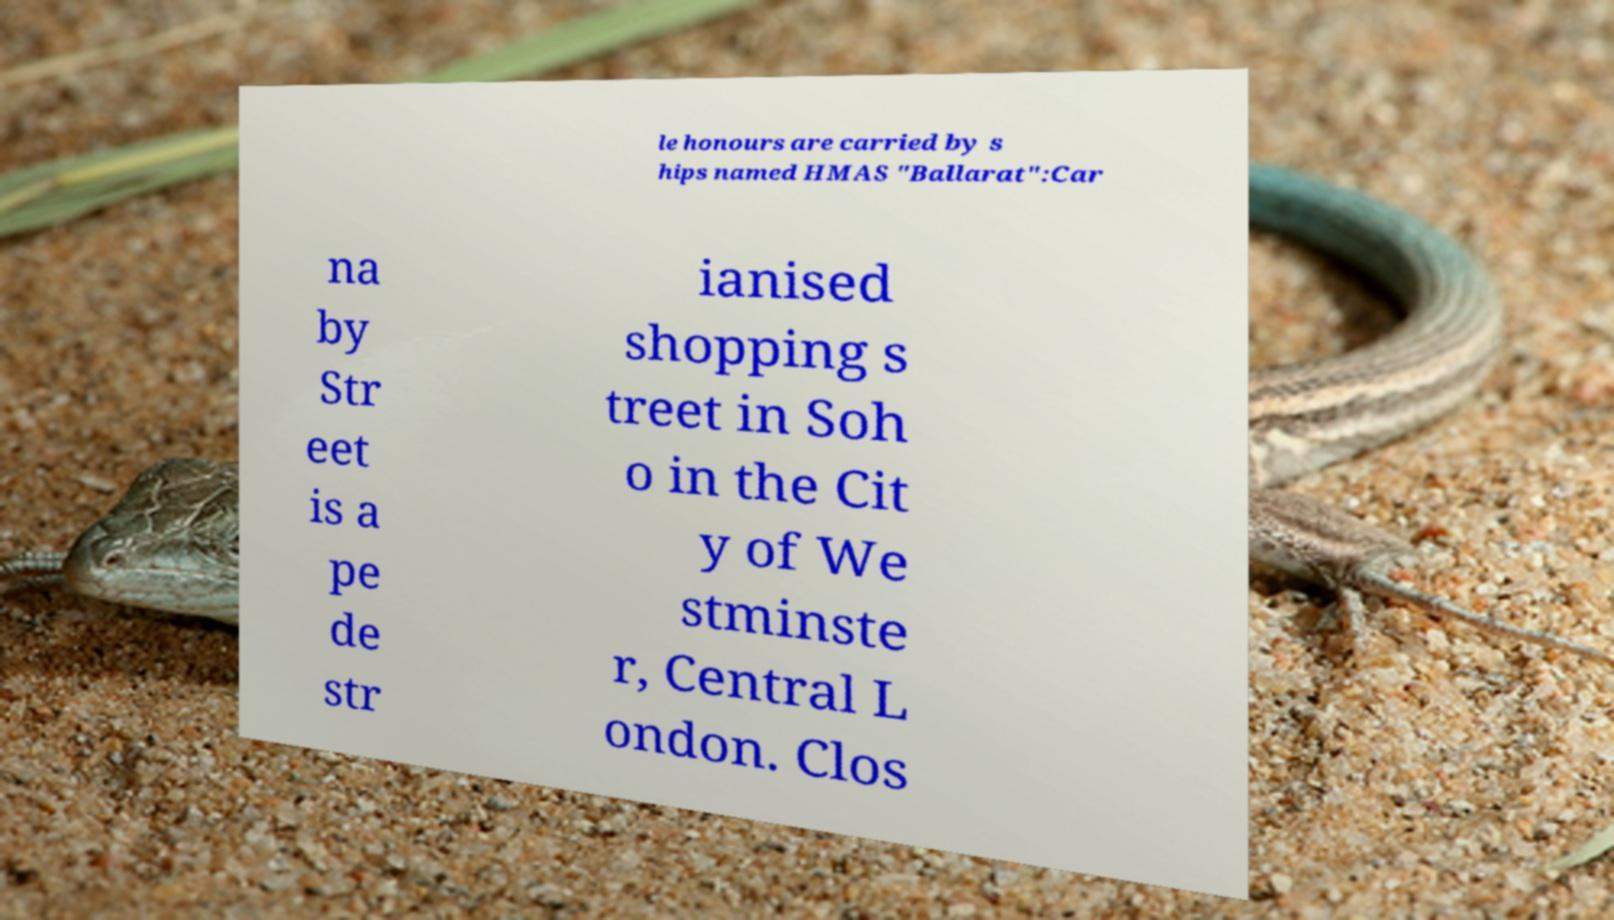Can you read and provide the text displayed in the image?This photo seems to have some interesting text. Can you extract and type it out for me? le honours are carried by s hips named HMAS "Ballarat":Car na by Str eet is a pe de str ianised shopping s treet in Soh o in the Cit y of We stminste r, Central L ondon. Clos 